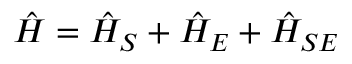<formula> <loc_0><loc_0><loc_500><loc_500>\hat { H } = \hat { H } _ { S } + \hat { H } _ { E } + \hat { H } _ { S E }</formula> 